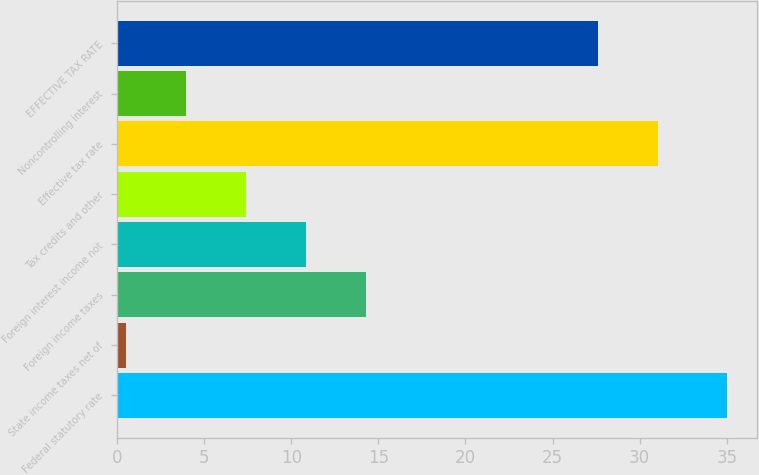Convert chart. <chart><loc_0><loc_0><loc_500><loc_500><bar_chart><fcel>Federal statutory rate<fcel>State income taxes net of<fcel>Foreign income taxes<fcel>Foreign interest income not<fcel>Tax credits and other<fcel>Effective tax rate<fcel>Noncontrolling interest<fcel>EFFECTIVE TAX RATE<nl><fcel>35<fcel>0.5<fcel>14.3<fcel>10.85<fcel>7.4<fcel>31.05<fcel>3.95<fcel>27.6<nl></chart> 